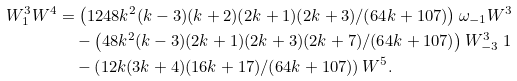<formula> <loc_0><loc_0><loc_500><loc_500>W ^ { 3 } _ { 1 } W ^ { 4 } & = \left ( 1 2 4 8 k ^ { 2 } ( k - 3 ) ( k + 2 ) ( 2 k + 1 ) ( 2 k + 3 ) / ( 6 4 k + 1 0 7 ) \right ) \omega _ { - 1 } W ^ { 3 } \\ & \quad - \left ( 4 8 k ^ { 2 } ( k - 3 ) ( 2 k + 1 ) ( 2 k + 3 ) ( 2 k + 7 ) / ( 6 4 k + 1 0 7 ) \right ) W ^ { 3 } _ { - 3 } \ 1 \\ & \quad - \left ( 1 2 k ( 3 k + 4 ) ( 1 6 k + 1 7 ) / ( 6 4 k + 1 0 7 ) \right ) W ^ { 5 } .</formula> 